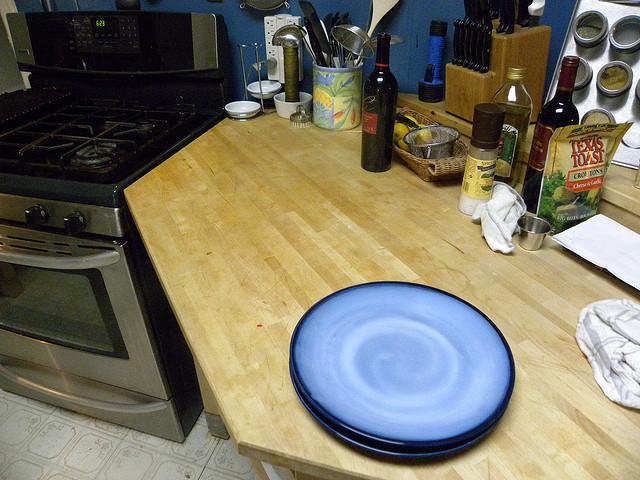How many people will eat on these plates?
Be succinct. 2. What appliances are in picture?
Concise answer only. Stove. What liquid is in the clear glass bottle?
Quick response, please. Oil. 